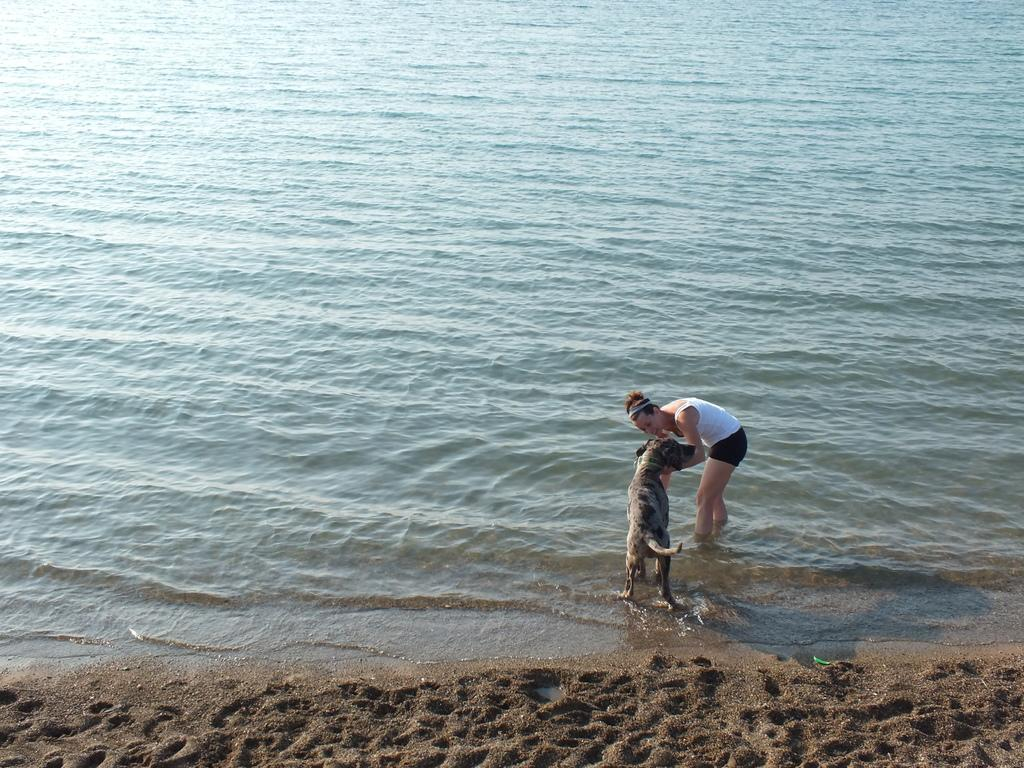What is the main subject of the image? There is a person standing in the image. Is there any other living creature present in the image? Yes, there is a dog beside the person. What type of terrain is visible at the bottom of the image? There is sand at the bottom of the image. What can be seen in the background of the image? There is a river visible in the background of the image. What type of polish is the person applying to the bike in the image? There is no bike present in the image, and therefore no polish or bike-related activity can be observed. 